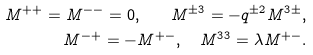<formula> <loc_0><loc_0><loc_500><loc_500>M ^ { + + } = M ^ { - - } = 0 , \quad M ^ { \pm 3 } = - q ^ { \pm 2 } M ^ { 3 \pm } , \\ M ^ { - + } = - M ^ { + - } , \quad M ^ { 3 3 } = \lambda M ^ { + - } .</formula> 